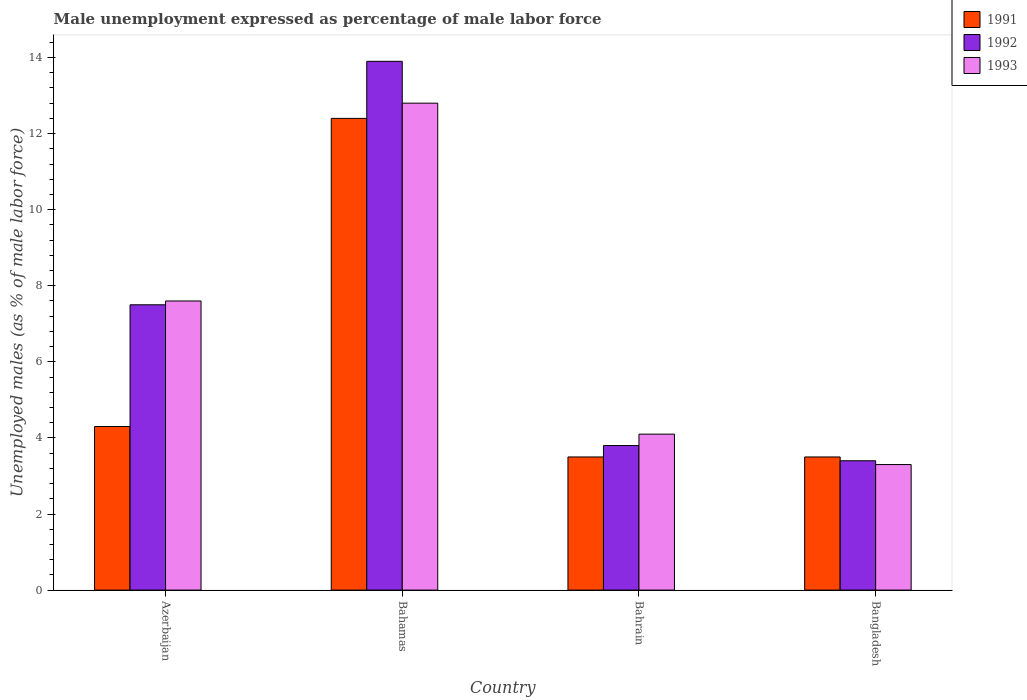How many different coloured bars are there?
Make the answer very short. 3. How many bars are there on the 1st tick from the left?
Your answer should be compact. 3. How many bars are there on the 4th tick from the right?
Offer a terse response. 3. What is the label of the 2nd group of bars from the left?
Keep it short and to the point. Bahamas. What is the unemployment in males in in 1992 in Bahamas?
Offer a terse response. 13.9. Across all countries, what is the maximum unemployment in males in in 1992?
Provide a short and direct response. 13.9. Across all countries, what is the minimum unemployment in males in in 1992?
Your answer should be very brief. 3.4. In which country was the unemployment in males in in 1993 maximum?
Provide a succinct answer. Bahamas. In which country was the unemployment in males in in 1991 minimum?
Make the answer very short. Bahrain. What is the total unemployment in males in in 1991 in the graph?
Provide a short and direct response. 23.7. What is the difference between the unemployment in males in in 1993 in Azerbaijan and that in Bahrain?
Provide a succinct answer. 3.5. What is the difference between the unemployment in males in in 1991 in Azerbaijan and the unemployment in males in in 1992 in Bahamas?
Offer a very short reply. -9.6. What is the average unemployment in males in in 1993 per country?
Make the answer very short. 6.95. What is the difference between the unemployment in males in of/in 1992 and unemployment in males in of/in 1991 in Azerbaijan?
Your answer should be compact. 3.2. What is the ratio of the unemployment in males in in 1991 in Bahamas to that in Bahrain?
Your response must be concise. 3.54. What is the difference between the highest and the second highest unemployment in males in in 1993?
Offer a terse response. 8.7. What is the difference between the highest and the lowest unemployment in males in in 1993?
Your answer should be compact. 9.5. What does the 2nd bar from the right in Bahamas represents?
Your response must be concise. 1992. Is it the case that in every country, the sum of the unemployment in males in in 1992 and unemployment in males in in 1991 is greater than the unemployment in males in in 1993?
Give a very brief answer. Yes. Are all the bars in the graph horizontal?
Provide a short and direct response. No. How many countries are there in the graph?
Offer a very short reply. 4. What is the difference between two consecutive major ticks on the Y-axis?
Offer a terse response. 2. Where does the legend appear in the graph?
Provide a succinct answer. Top right. How many legend labels are there?
Keep it short and to the point. 3. What is the title of the graph?
Give a very brief answer. Male unemployment expressed as percentage of male labor force. What is the label or title of the Y-axis?
Offer a very short reply. Unemployed males (as % of male labor force). What is the Unemployed males (as % of male labor force) in 1991 in Azerbaijan?
Offer a very short reply. 4.3. What is the Unemployed males (as % of male labor force) of 1992 in Azerbaijan?
Keep it short and to the point. 7.5. What is the Unemployed males (as % of male labor force) in 1993 in Azerbaijan?
Your answer should be very brief. 7.6. What is the Unemployed males (as % of male labor force) in 1991 in Bahamas?
Your response must be concise. 12.4. What is the Unemployed males (as % of male labor force) of 1992 in Bahamas?
Your answer should be very brief. 13.9. What is the Unemployed males (as % of male labor force) of 1993 in Bahamas?
Your response must be concise. 12.8. What is the Unemployed males (as % of male labor force) of 1992 in Bahrain?
Keep it short and to the point. 3.8. What is the Unemployed males (as % of male labor force) of 1993 in Bahrain?
Make the answer very short. 4.1. What is the Unemployed males (as % of male labor force) in 1991 in Bangladesh?
Keep it short and to the point. 3.5. What is the Unemployed males (as % of male labor force) in 1992 in Bangladesh?
Your answer should be compact. 3.4. What is the Unemployed males (as % of male labor force) in 1993 in Bangladesh?
Offer a terse response. 3.3. Across all countries, what is the maximum Unemployed males (as % of male labor force) in 1991?
Provide a succinct answer. 12.4. Across all countries, what is the maximum Unemployed males (as % of male labor force) in 1992?
Provide a succinct answer. 13.9. Across all countries, what is the maximum Unemployed males (as % of male labor force) in 1993?
Make the answer very short. 12.8. Across all countries, what is the minimum Unemployed males (as % of male labor force) of 1991?
Offer a very short reply. 3.5. Across all countries, what is the minimum Unemployed males (as % of male labor force) in 1992?
Ensure brevity in your answer.  3.4. Across all countries, what is the minimum Unemployed males (as % of male labor force) in 1993?
Your answer should be very brief. 3.3. What is the total Unemployed males (as % of male labor force) of 1991 in the graph?
Provide a short and direct response. 23.7. What is the total Unemployed males (as % of male labor force) of 1992 in the graph?
Offer a terse response. 28.6. What is the total Unemployed males (as % of male labor force) of 1993 in the graph?
Make the answer very short. 27.8. What is the difference between the Unemployed males (as % of male labor force) in 1991 in Azerbaijan and that in Bahamas?
Your answer should be compact. -8.1. What is the difference between the Unemployed males (as % of male labor force) in 1992 in Azerbaijan and that in Bahamas?
Make the answer very short. -6.4. What is the difference between the Unemployed males (as % of male labor force) of 1993 in Azerbaijan and that in Bahamas?
Your response must be concise. -5.2. What is the difference between the Unemployed males (as % of male labor force) in 1991 in Azerbaijan and that in Bahrain?
Ensure brevity in your answer.  0.8. What is the difference between the Unemployed males (as % of male labor force) of 1993 in Azerbaijan and that in Bahrain?
Keep it short and to the point. 3.5. What is the difference between the Unemployed males (as % of male labor force) of 1991 in Azerbaijan and that in Bangladesh?
Keep it short and to the point. 0.8. What is the difference between the Unemployed males (as % of male labor force) in 1993 in Azerbaijan and that in Bangladesh?
Your answer should be compact. 4.3. What is the difference between the Unemployed males (as % of male labor force) in 1993 in Bahamas and that in Bahrain?
Your answer should be compact. 8.7. What is the difference between the Unemployed males (as % of male labor force) in 1993 in Bahamas and that in Bangladesh?
Keep it short and to the point. 9.5. What is the difference between the Unemployed males (as % of male labor force) of 1991 in Bahrain and that in Bangladesh?
Provide a short and direct response. 0. What is the difference between the Unemployed males (as % of male labor force) in 1992 in Bahrain and that in Bangladesh?
Make the answer very short. 0.4. What is the difference between the Unemployed males (as % of male labor force) of 1991 in Azerbaijan and the Unemployed males (as % of male labor force) of 1992 in Bahamas?
Keep it short and to the point. -9.6. What is the difference between the Unemployed males (as % of male labor force) in 1991 in Azerbaijan and the Unemployed males (as % of male labor force) in 1993 in Bahamas?
Offer a terse response. -8.5. What is the difference between the Unemployed males (as % of male labor force) of 1992 in Azerbaijan and the Unemployed males (as % of male labor force) of 1993 in Bahamas?
Offer a very short reply. -5.3. What is the difference between the Unemployed males (as % of male labor force) of 1991 in Azerbaijan and the Unemployed males (as % of male labor force) of 1993 in Bahrain?
Your answer should be compact. 0.2. What is the difference between the Unemployed males (as % of male labor force) in 1992 in Azerbaijan and the Unemployed males (as % of male labor force) in 1993 in Bahrain?
Your answer should be compact. 3.4. What is the difference between the Unemployed males (as % of male labor force) in 1991 in Azerbaijan and the Unemployed males (as % of male labor force) in 1992 in Bangladesh?
Make the answer very short. 0.9. What is the difference between the Unemployed males (as % of male labor force) of 1992 in Azerbaijan and the Unemployed males (as % of male labor force) of 1993 in Bangladesh?
Offer a very short reply. 4.2. What is the difference between the Unemployed males (as % of male labor force) in 1992 in Bahamas and the Unemployed males (as % of male labor force) in 1993 in Bahrain?
Offer a very short reply. 9.8. What is the difference between the Unemployed males (as % of male labor force) in 1992 in Bahamas and the Unemployed males (as % of male labor force) in 1993 in Bangladesh?
Your response must be concise. 10.6. What is the difference between the Unemployed males (as % of male labor force) of 1991 in Bahrain and the Unemployed males (as % of male labor force) of 1992 in Bangladesh?
Ensure brevity in your answer.  0.1. What is the average Unemployed males (as % of male labor force) of 1991 per country?
Keep it short and to the point. 5.92. What is the average Unemployed males (as % of male labor force) in 1992 per country?
Offer a very short reply. 7.15. What is the average Unemployed males (as % of male labor force) of 1993 per country?
Give a very brief answer. 6.95. What is the difference between the Unemployed males (as % of male labor force) of 1991 and Unemployed males (as % of male labor force) of 1993 in Azerbaijan?
Your answer should be compact. -3.3. What is the difference between the Unemployed males (as % of male labor force) in 1992 and Unemployed males (as % of male labor force) in 1993 in Azerbaijan?
Provide a short and direct response. -0.1. What is the difference between the Unemployed males (as % of male labor force) in 1992 and Unemployed males (as % of male labor force) in 1993 in Bahamas?
Your answer should be very brief. 1.1. What is the difference between the Unemployed males (as % of male labor force) of 1991 and Unemployed males (as % of male labor force) of 1992 in Bahrain?
Make the answer very short. -0.3. What is the difference between the Unemployed males (as % of male labor force) of 1991 and Unemployed males (as % of male labor force) of 1993 in Bahrain?
Your answer should be very brief. -0.6. What is the difference between the Unemployed males (as % of male labor force) of 1992 and Unemployed males (as % of male labor force) of 1993 in Bahrain?
Provide a succinct answer. -0.3. What is the difference between the Unemployed males (as % of male labor force) of 1991 and Unemployed males (as % of male labor force) of 1992 in Bangladesh?
Make the answer very short. 0.1. What is the ratio of the Unemployed males (as % of male labor force) of 1991 in Azerbaijan to that in Bahamas?
Give a very brief answer. 0.35. What is the ratio of the Unemployed males (as % of male labor force) in 1992 in Azerbaijan to that in Bahamas?
Your answer should be compact. 0.54. What is the ratio of the Unemployed males (as % of male labor force) of 1993 in Azerbaijan to that in Bahamas?
Make the answer very short. 0.59. What is the ratio of the Unemployed males (as % of male labor force) in 1991 in Azerbaijan to that in Bahrain?
Give a very brief answer. 1.23. What is the ratio of the Unemployed males (as % of male labor force) of 1992 in Azerbaijan to that in Bahrain?
Your response must be concise. 1.97. What is the ratio of the Unemployed males (as % of male labor force) of 1993 in Azerbaijan to that in Bahrain?
Your answer should be compact. 1.85. What is the ratio of the Unemployed males (as % of male labor force) of 1991 in Azerbaijan to that in Bangladesh?
Make the answer very short. 1.23. What is the ratio of the Unemployed males (as % of male labor force) of 1992 in Azerbaijan to that in Bangladesh?
Provide a succinct answer. 2.21. What is the ratio of the Unemployed males (as % of male labor force) of 1993 in Azerbaijan to that in Bangladesh?
Offer a very short reply. 2.3. What is the ratio of the Unemployed males (as % of male labor force) of 1991 in Bahamas to that in Bahrain?
Offer a very short reply. 3.54. What is the ratio of the Unemployed males (as % of male labor force) of 1992 in Bahamas to that in Bahrain?
Provide a succinct answer. 3.66. What is the ratio of the Unemployed males (as % of male labor force) of 1993 in Bahamas to that in Bahrain?
Provide a short and direct response. 3.12. What is the ratio of the Unemployed males (as % of male labor force) of 1991 in Bahamas to that in Bangladesh?
Give a very brief answer. 3.54. What is the ratio of the Unemployed males (as % of male labor force) in 1992 in Bahamas to that in Bangladesh?
Your response must be concise. 4.09. What is the ratio of the Unemployed males (as % of male labor force) in 1993 in Bahamas to that in Bangladesh?
Make the answer very short. 3.88. What is the ratio of the Unemployed males (as % of male labor force) in 1992 in Bahrain to that in Bangladesh?
Provide a succinct answer. 1.12. What is the ratio of the Unemployed males (as % of male labor force) of 1993 in Bahrain to that in Bangladesh?
Give a very brief answer. 1.24. What is the difference between the highest and the second highest Unemployed males (as % of male labor force) in 1991?
Keep it short and to the point. 8.1. What is the difference between the highest and the second highest Unemployed males (as % of male labor force) in 1992?
Your answer should be very brief. 6.4. What is the difference between the highest and the lowest Unemployed males (as % of male labor force) in 1992?
Make the answer very short. 10.5. 